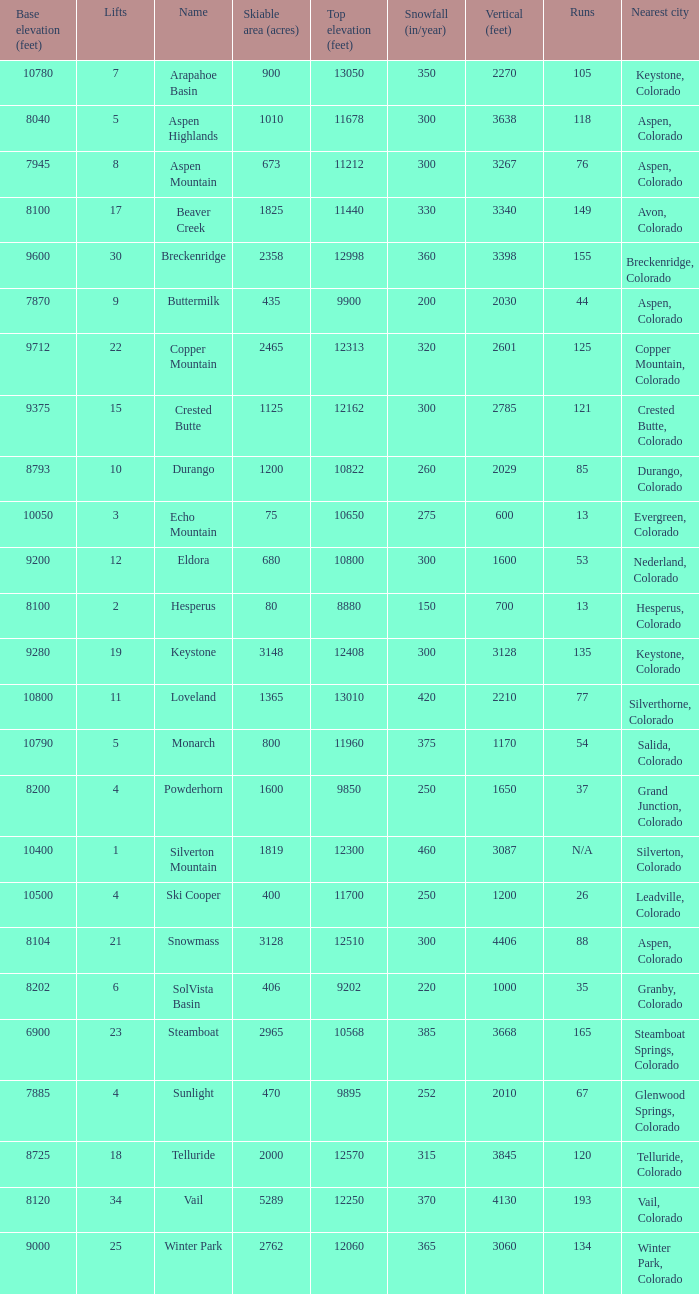How many resorts have 118 runs? 1.0. 